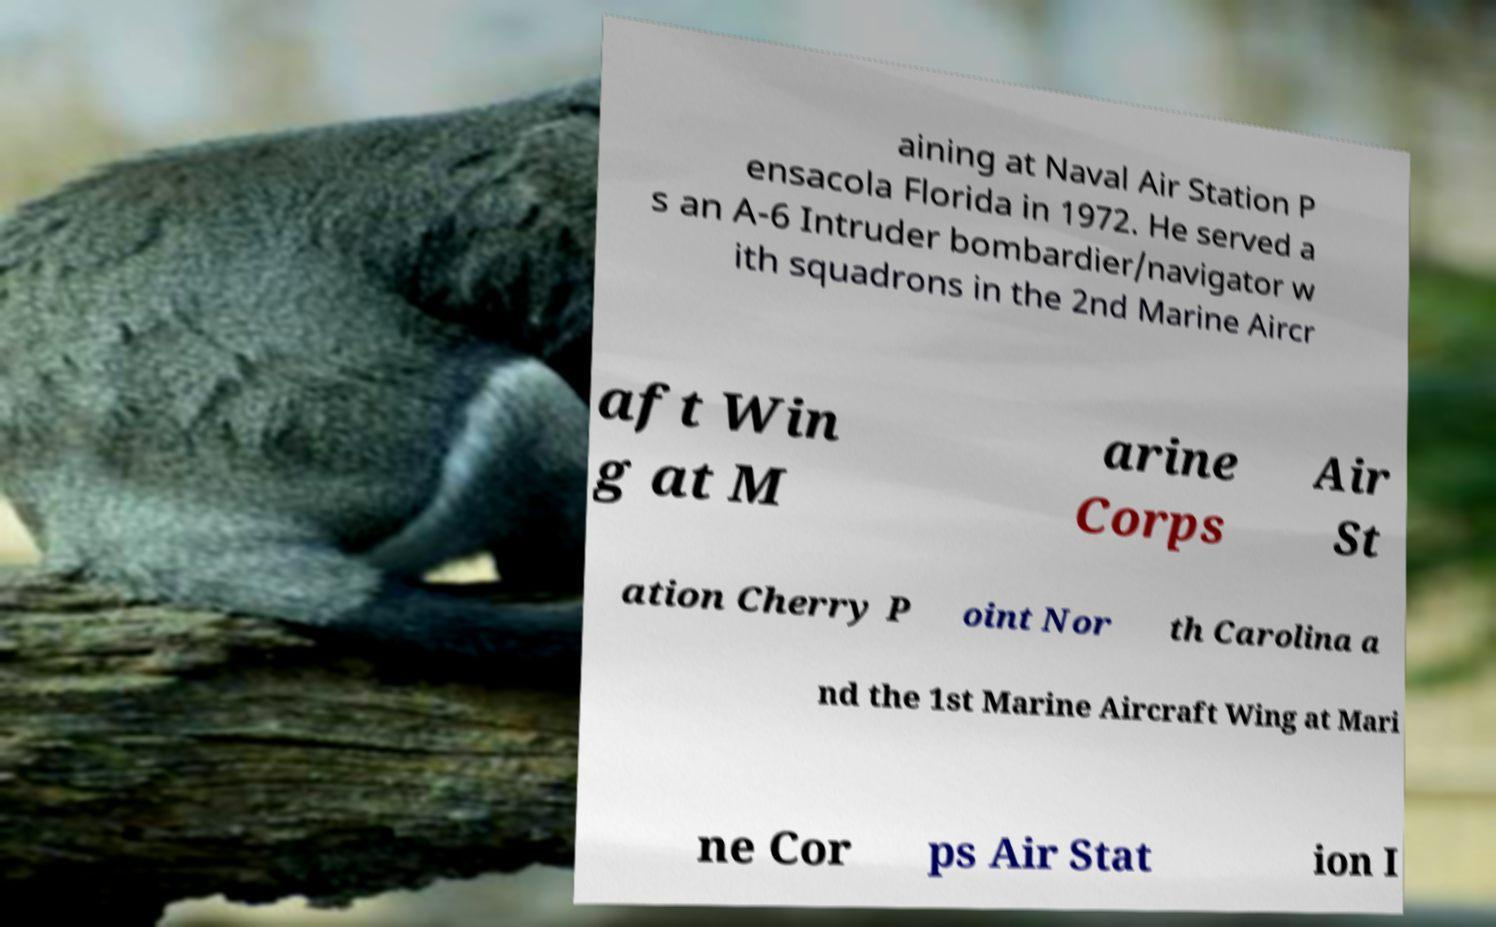There's text embedded in this image that I need extracted. Can you transcribe it verbatim? aining at Naval Air Station P ensacola Florida in 1972. He served a s an A-6 Intruder bombardier/navigator w ith squadrons in the 2nd Marine Aircr aft Win g at M arine Corps Air St ation Cherry P oint Nor th Carolina a nd the 1st Marine Aircraft Wing at Mari ne Cor ps Air Stat ion I 